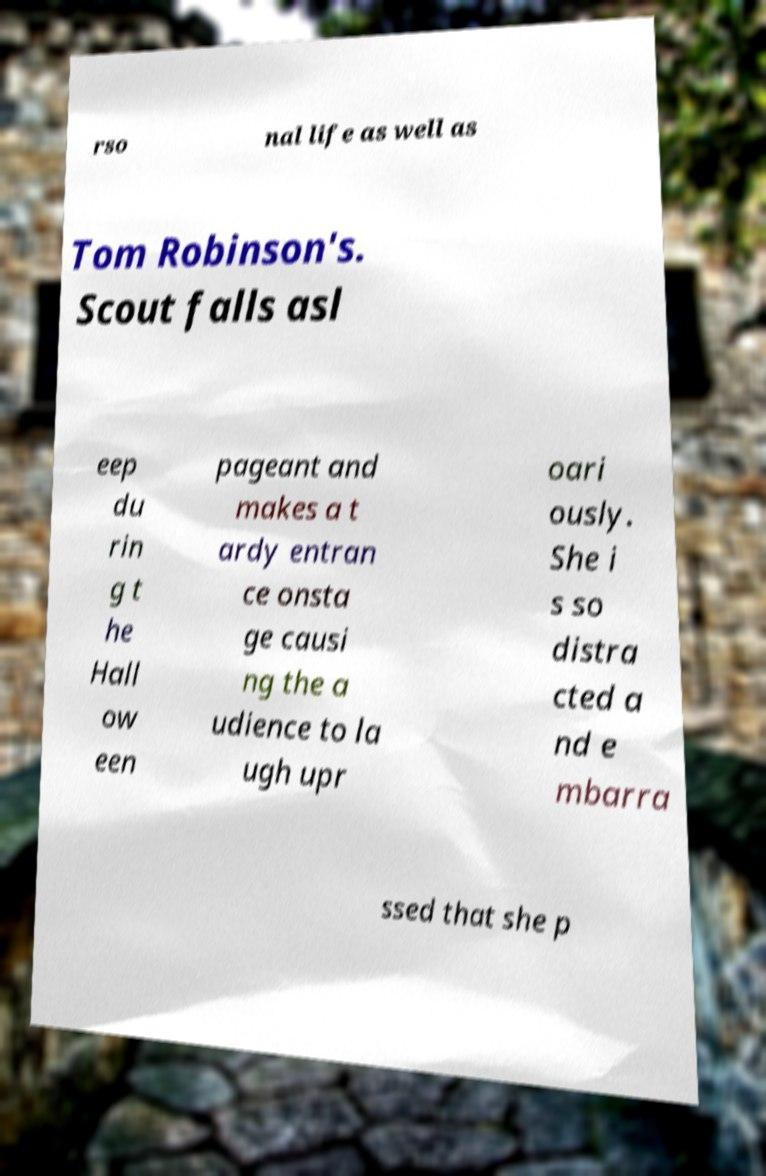Please read and relay the text visible in this image. What does it say? rso nal life as well as Tom Robinson's. Scout falls asl eep du rin g t he Hall ow een pageant and makes a t ardy entran ce onsta ge causi ng the a udience to la ugh upr oari ously. She i s so distra cted a nd e mbarra ssed that she p 